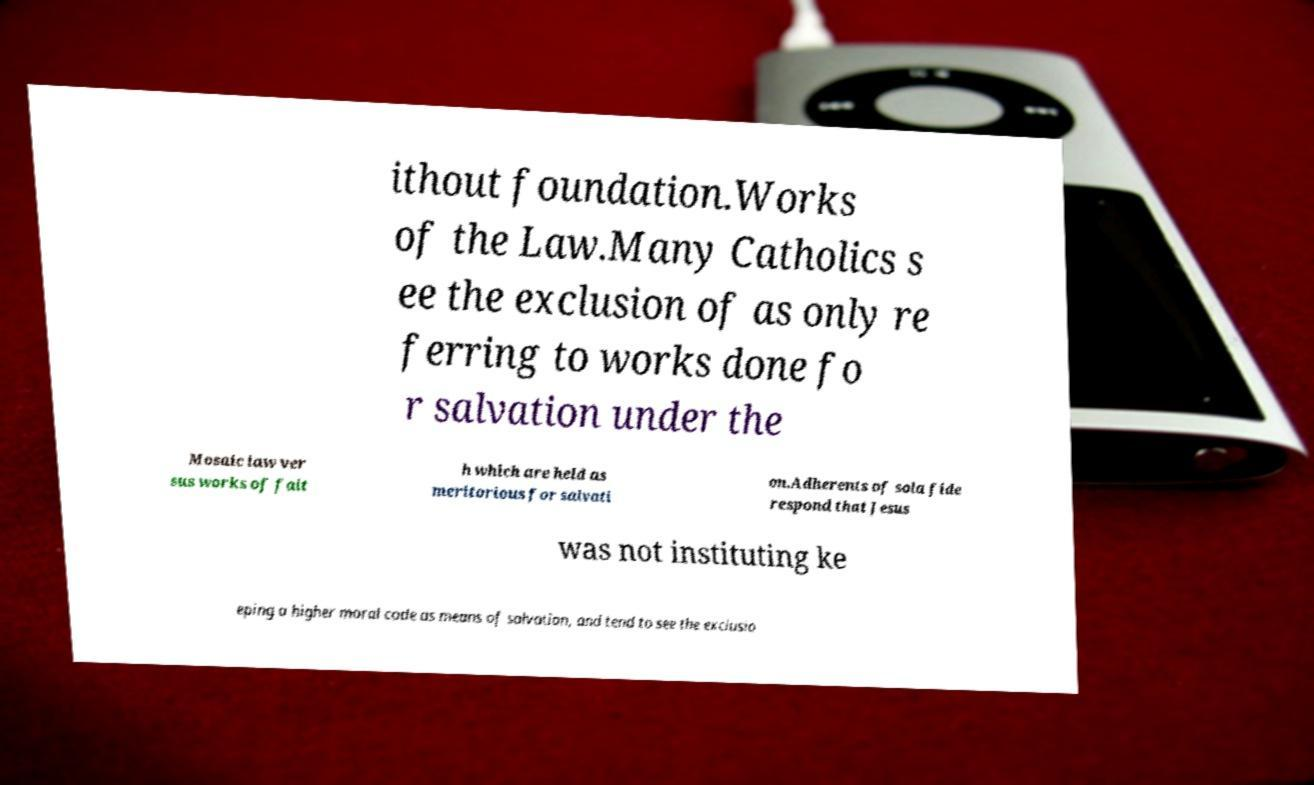What messages or text are displayed in this image? I need them in a readable, typed format. ithout foundation.Works of the Law.Many Catholics s ee the exclusion of as only re ferring to works done fo r salvation under the Mosaic law ver sus works of fait h which are held as meritorious for salvati on.Adherents of sola fide respond that Jesus was not instituting ke eping a higher moral code as means of salvation, and tend to see the exclusio 